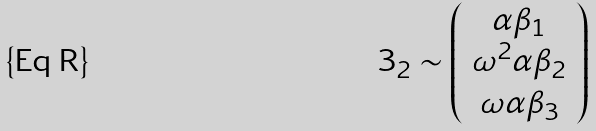Convert formula to latex. <formula><loc_0><loc_0><loc_500><loc_500>3 _ { 2 } \sim \left ( \begin{array} { c } \alpha \beta _ { 1 } \\ \omega ^ { 2 } \alpha \beta _ { 2 } \\ \omega \alpha \beta _ { 3 } \end{array} \right )</formula> 